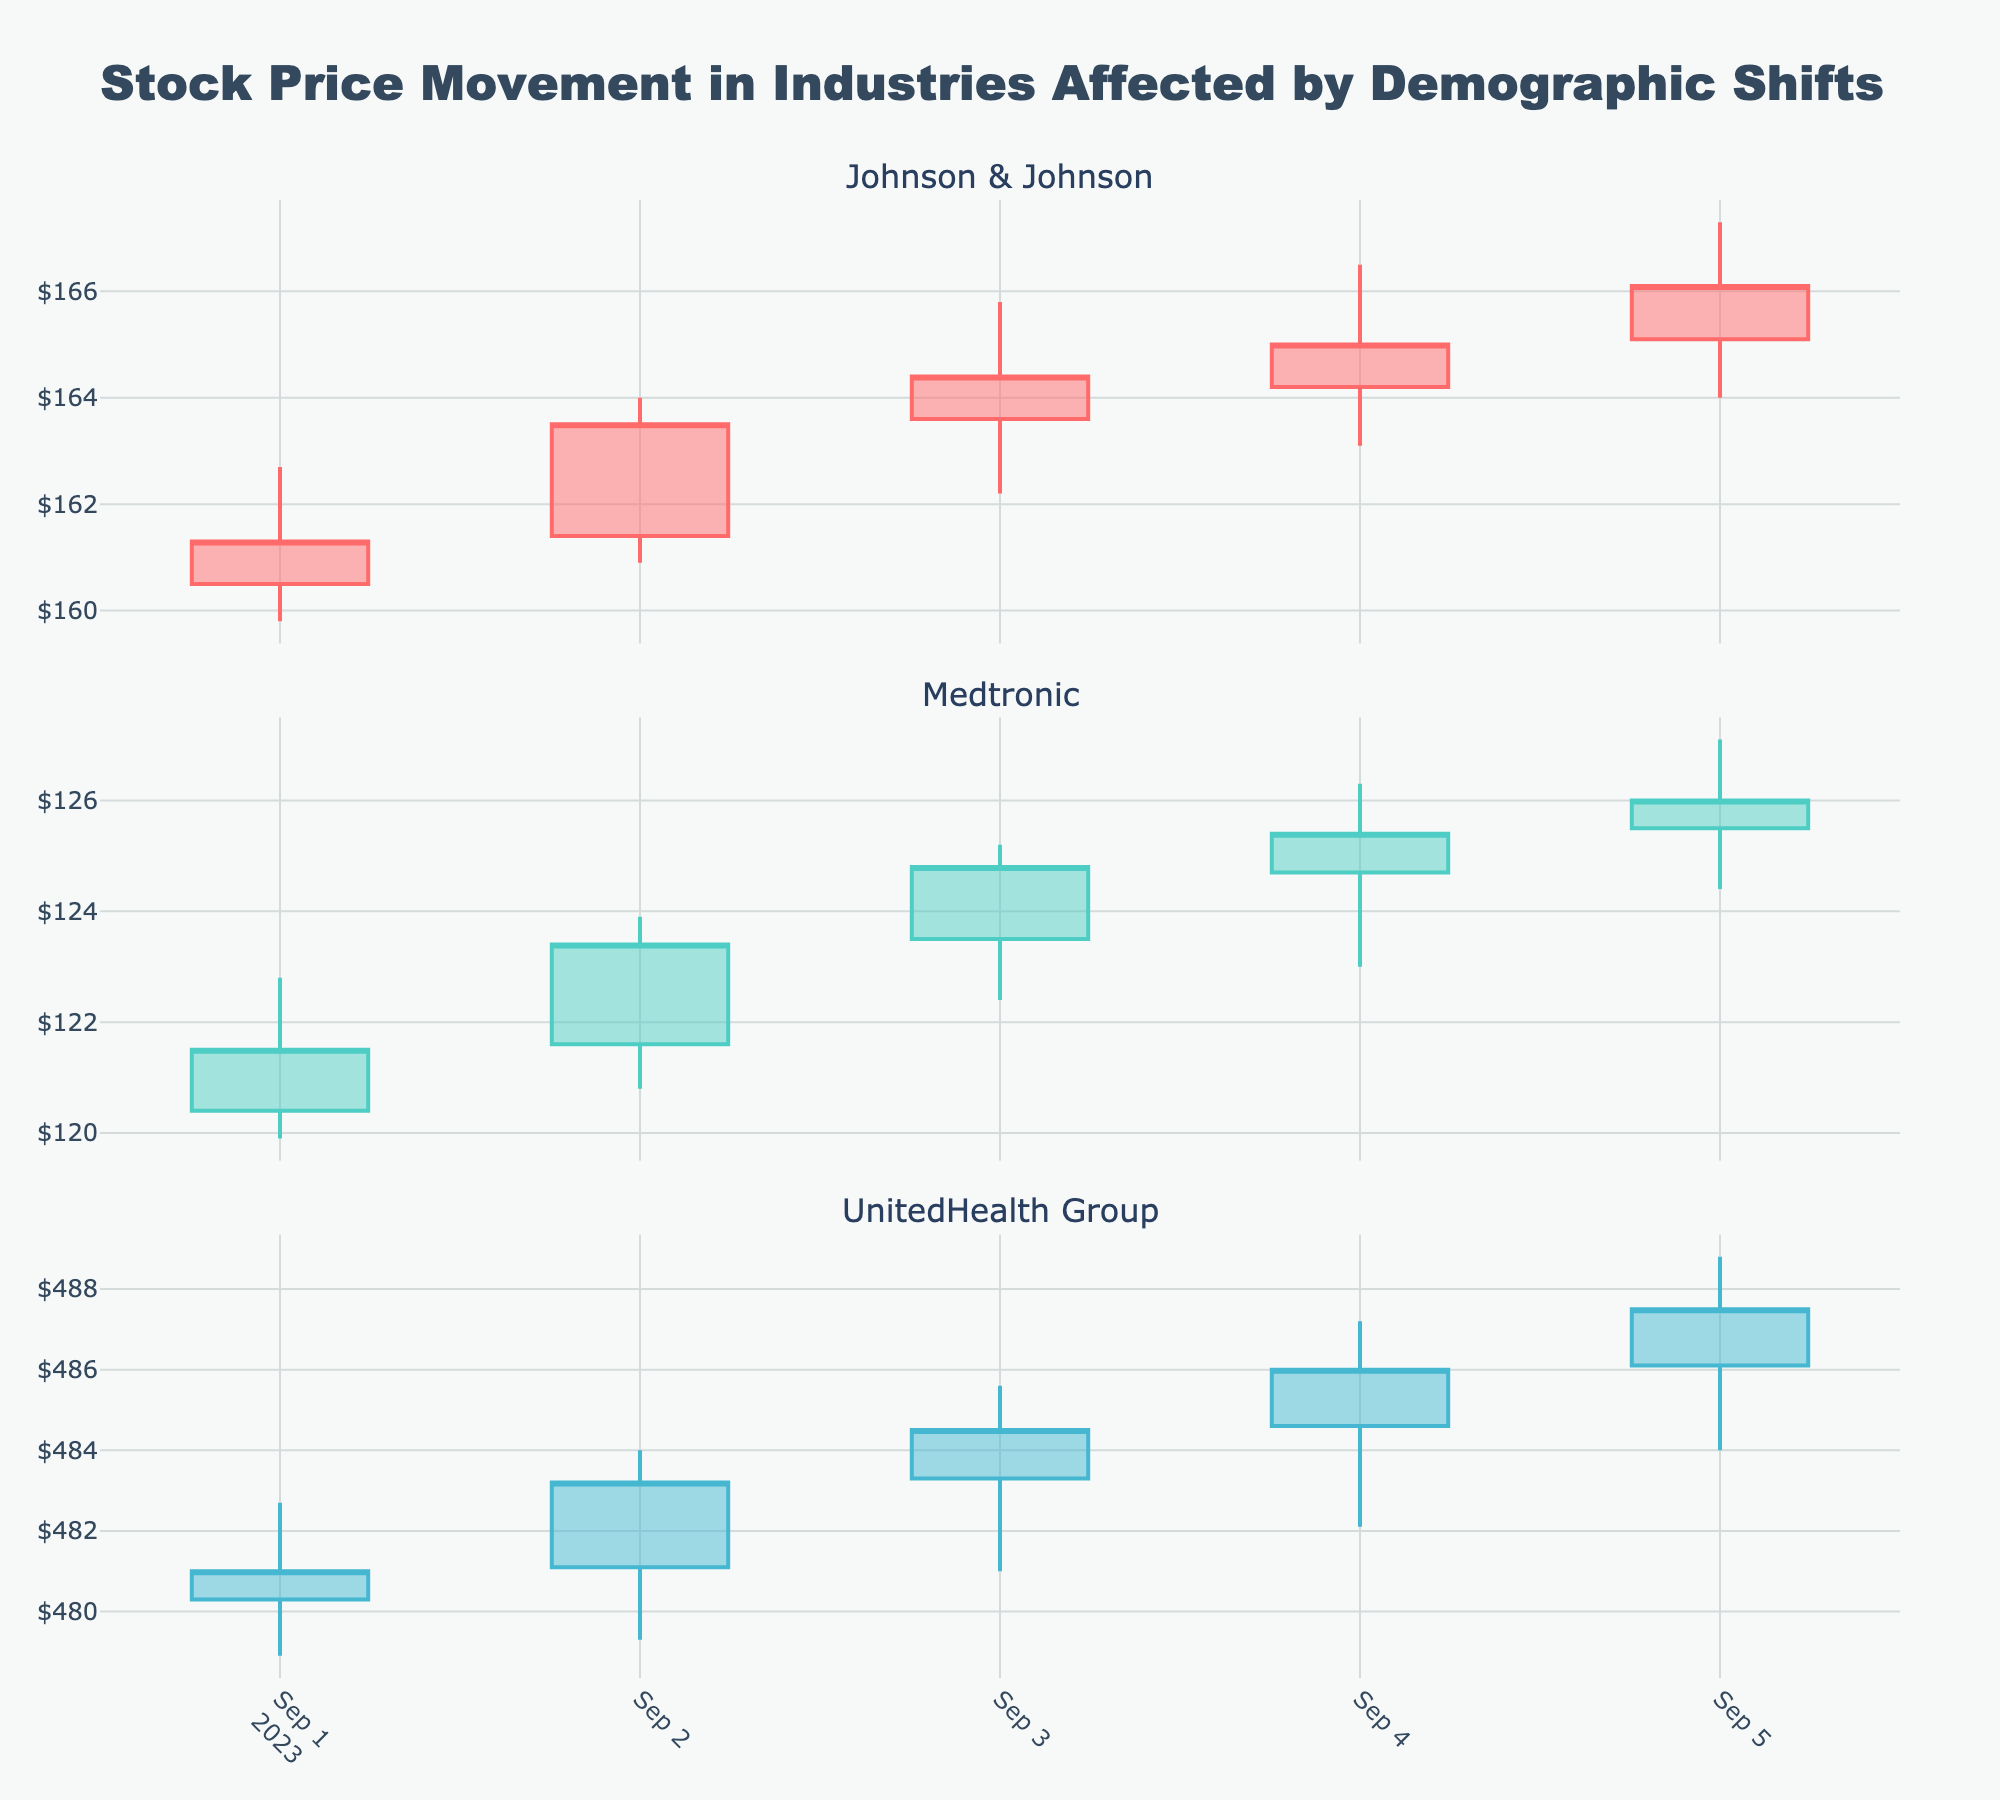How many days are shown in the stock price movement for Medtronic? Count the number of candlestick bars for Medtronic in the figure. Each bar represents one day.
Answer: 5 Which company has the highest closing price on 2023-09-05? Check the closing prices for all companies on 2023-09-05 and compare them. UnitedHealth Group's closing price is highest at 487.5.
Answer: UnitedHealth Group What is the difference between the highest and lowest prices for Johnson & Johnson on 2023-09-03? Look at the candlestick for Johnson & Johnson on 2023-09-03. The highest price is 165.8, and the lowest is 162.2. The difference is 165.8 - 162.2 = 3.6.
Answer: 3.6 Which company shows the most significant price increase from opening to closing price on 2023-09-04? Compare the difference between the opening and closing prices for all companies on 2023-09-04. Johnson & Johnson increased from 164.2 to 165.0, Medtronic from 124.7 to 125.4, and UnitedHealth Group from 484.6 to 486.0. The highest increase is for Johnson & Johnson (0.8).
Answer: Johnson & Johnson What is the overall trend of Medtronic's stock price from 2023-09-01 to 2023-09-05? Observe the closing prices of Medtronic from September 1 to September 5. The prices show an increasing trend (121.5 to 126.0).
Answer: Increasing Among the three companies, which one had the highest trading volume on 2023-09-01? Compare the trading volumes listed for each company on 2023-09-01. Johnson & Johnson had a volume of 1,052,000, Medtronic had 915,000, and UnitedHealth Group had 501,000. The highest volume is for Johnson & Johnson.
Answer: Johnson & Johnson For Johnson & Johnson, what is the average closing price over the 5 days? Sum the closing prices for Johnson & Johnson over the 5 days and divide by 5. The sum is 161.3 + 163.5 + 164.4 + 165.0 + 166.1 = 820.3. The average is 820.3 / 5 = 164.06.
Answer: 164.06 Which day shows the highest volatility (difference between high and low prices) for UnitedHealth Group? Calculate the difference between the high and low prices for each day for UnitedHealth Group. The differences are: 2023-09-01 (3.8), 2023-09-02 (4.7), 2023-09-03 (4.6), 2023-09-04 (5.1), 2023-09-05 (4.8). The highest volatility is on 2023-09-04.
Answer: 2023-09-04 Has Johnson & Johnson experienced any days where the closing price was lower than the opening price? Check if there are any red candlesticks for Johnson & Johnson, indicating a closing price lower than the opening price. There are no red candlesticks for Johnson & Johnson.
Answer: No 